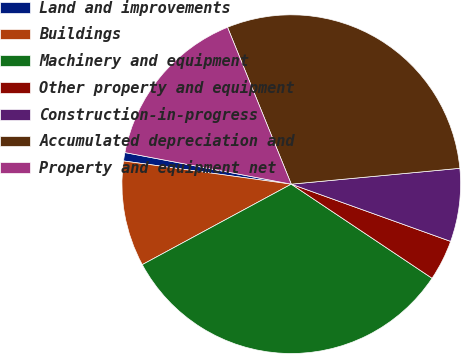Convert chart. <chart><loc_0><loc_0><loc_500><loc_500><pie_chart><fcel>Land and improvements<fcel>Buildings<fcel>Machinery and equipment<fcel>Other property and equipment<fcel>Construction-in-progress<fcel>Accumulated depreciation and<fcel>Property and equipment net<nl><fcel>0.8%<fcel>10.07%<fcel>32.74%<fcel>3.89%<fcel>6.98%<fcel>29.65%<fcel>15.87%<nl></chart> 